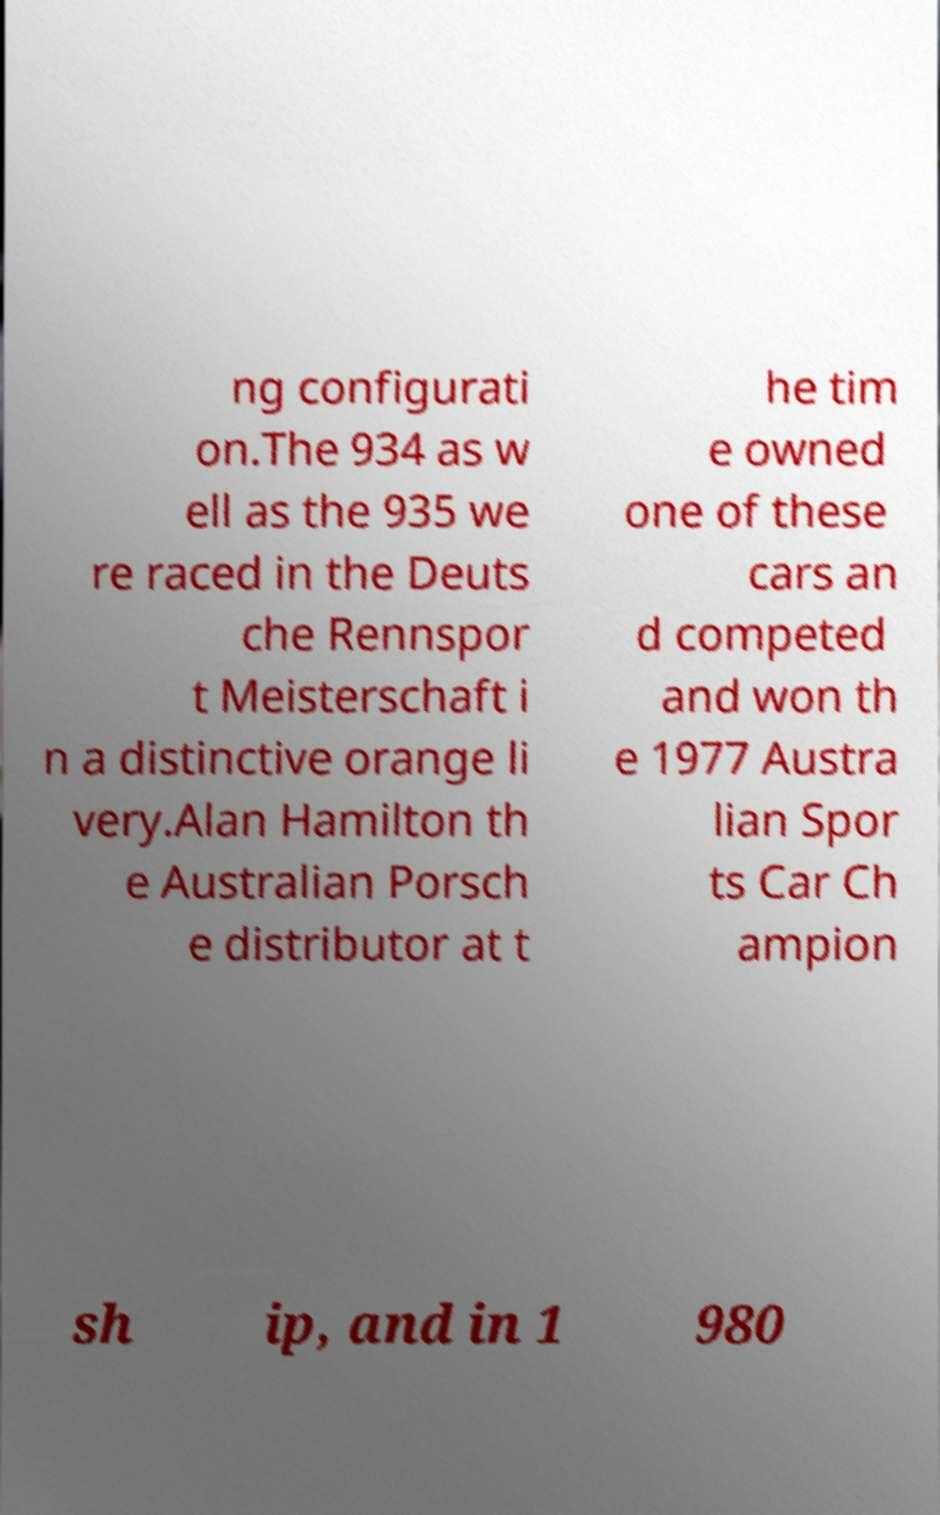What messages or text are displayed in this image? I need them in a readable, typed format. ng configurati on.The 934 as w ell as the 935 we re raced in the Deuts che Rennspor t Meisterschaft i n a distinctive orange li very.Alan Hamilton th e Australian Porsch e distributor at t he tim e owned one of these cars an d competed and won th e 1977 Austra lian Spor ts Car Ch ampion sh ip, and in 1 980 